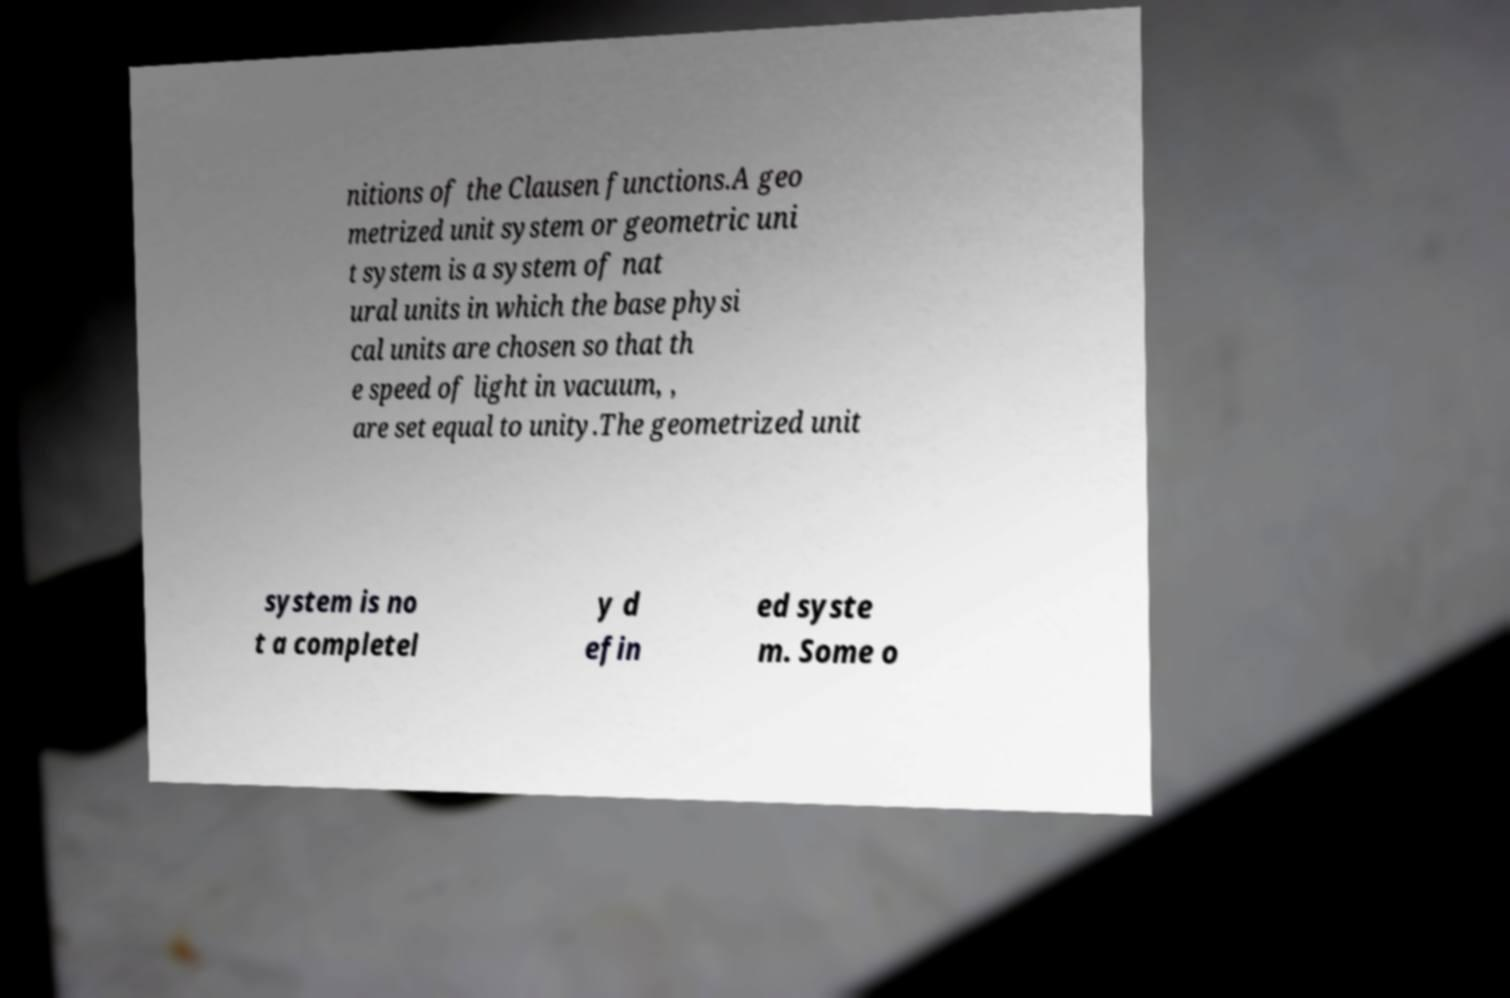Can you read and provide the text displayed in the image?This photo seems to have some interesting text. Can you extract and type it out for me? nitions of the Clausen functions.A geo metrized unit system or geometric uni t system is a system of nat ural units in which the base physi cal units are chosen so that th e speed of light in vacuum, , are set equal to unity.The geometrized unit system is no t a completel y d efin ed syste m. Some o 